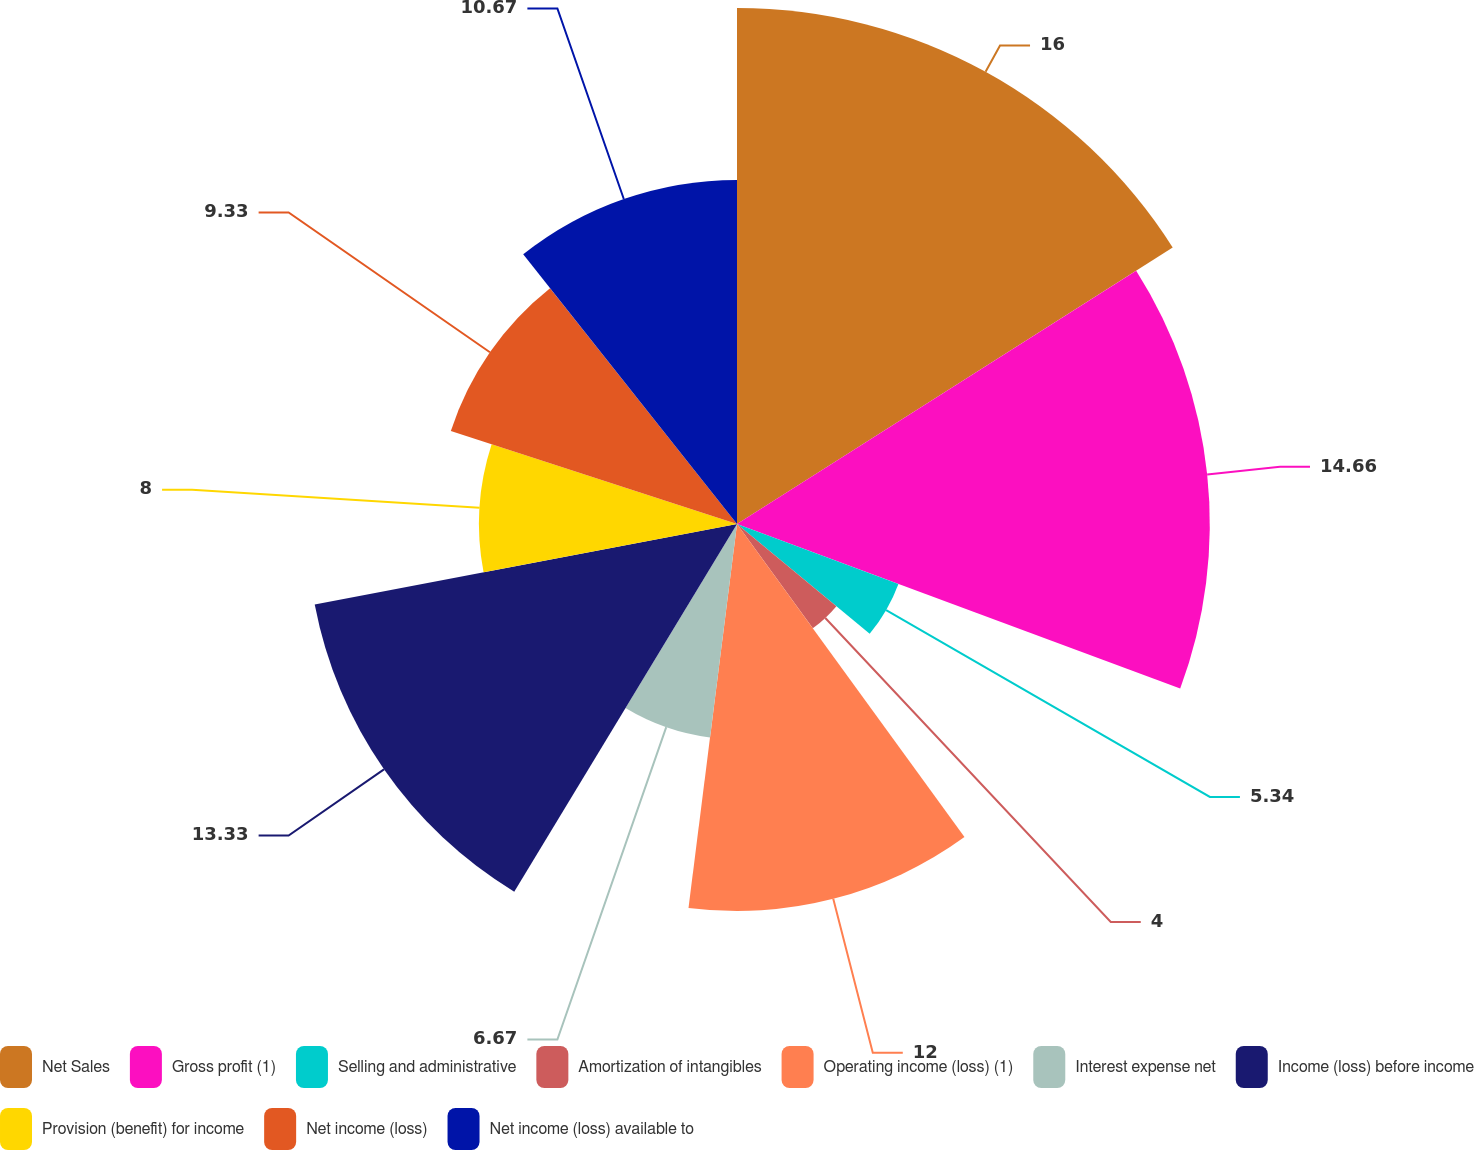Convert chart to OTSL. <chart><loc_0><loc_0><loc_500><loc_500><pie_chart><fcel>Net Sales<fcel>Gross profit (1)<fcel>Selling and administrative<fcel>Amortization of intangibles<fcel>Operating income (loss) (1)<fcel>Interest expense net<fcel>Income (loss) before income<fcel>Provision (benefit) for income<fcel>Net income (loss)<fcel>Net income (loss) available to<nl><fcel>16.0%<fcel>14.66%<fcel>5.34%<fcel>4.0%<fcel>12.0%<fcel>6.67%<fcel>13.33%<fcel>8.0%<fcel>9.33%<fcel>10.67%<nl></chart> 